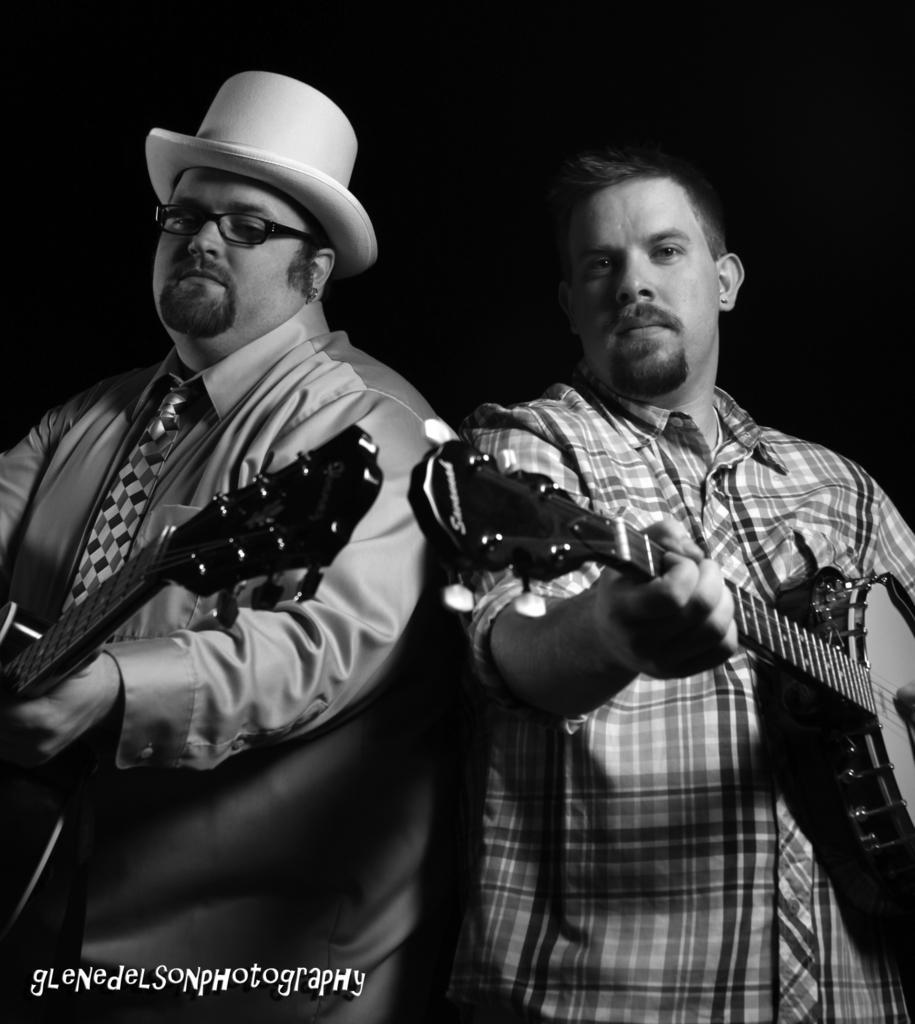Can you describe this image briefly? This is a black and white image. In the center of the image there are two persons holding guitar. At the bottom of the image there is text. 